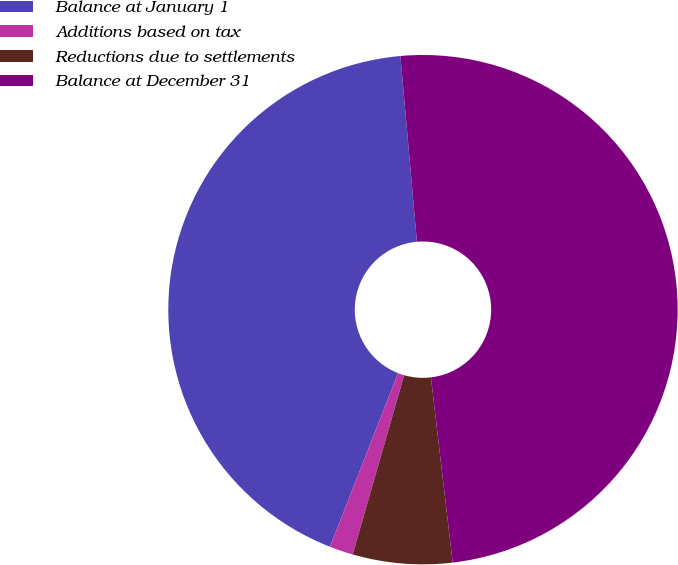Convert chart to OTSL. <chart><loc_0><loc_0><loc_500><loc_500><pie_chart><fcel>Balance at January 1<fcel>Additions based on tax<fcel>Reductions due to settlements<fcel>Balance at December 31<nl><fcel>42.64%<fcel>1.5%<fcel>6.31%<fcel>49.55%<nl></chart> 